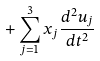Convert formula to latex. <formula><loc_0><loc_0><loc_500><loc_500>+ \sum _ { j = 1 } ^ { 3 } x _ { j } \frac { d ^ { 2 } u _ { j } } { d t ^ { 2 } }</formula> 